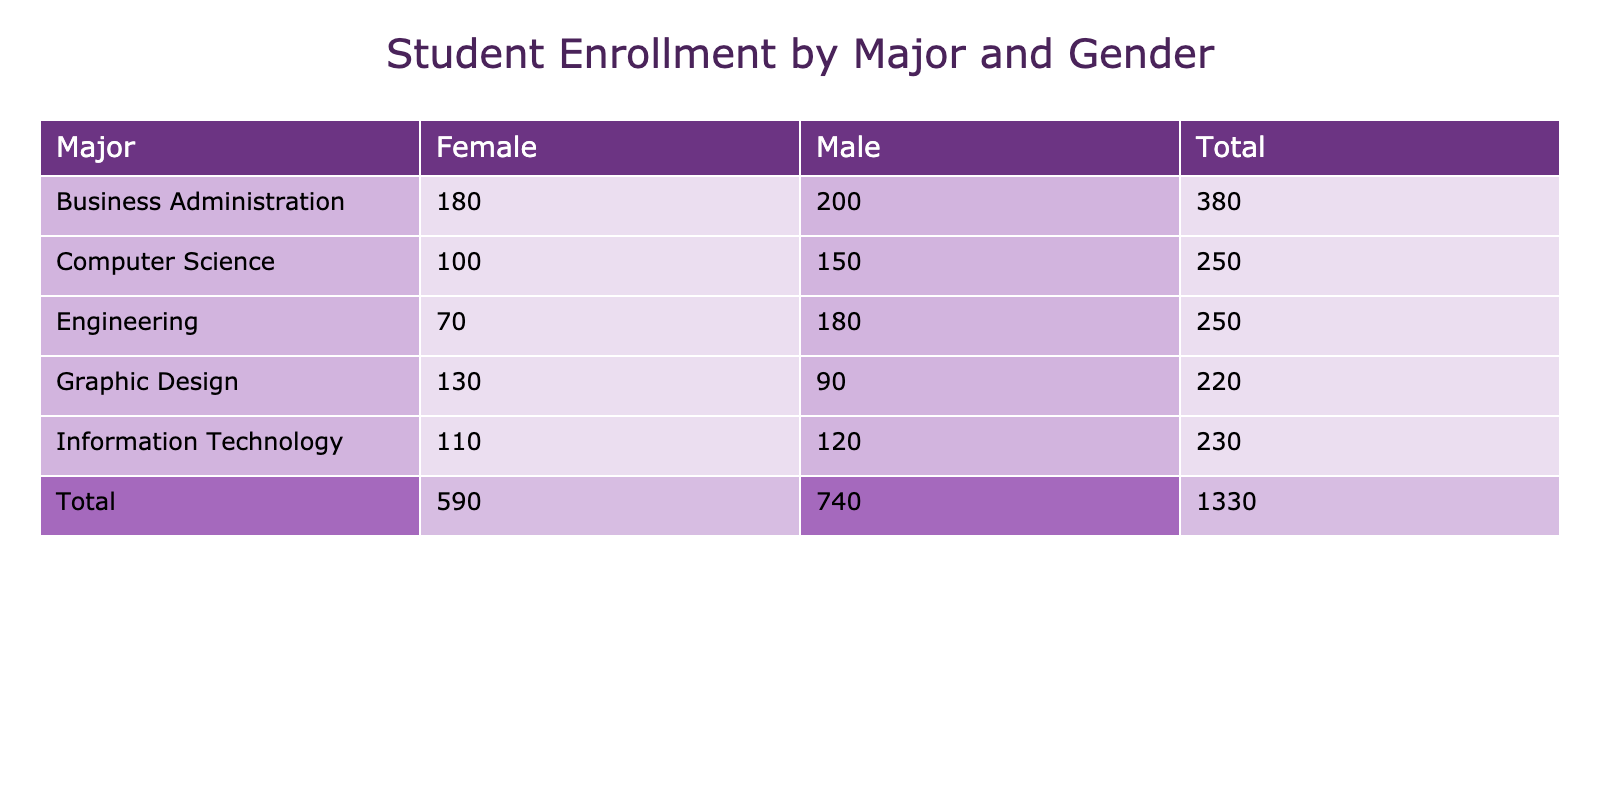What is the total number of female students in Engineering? In the table, we look under the Engineering major and find the number of female students, which is listed as 70.
Answer: 70 How many more male students are there in Business Administration than in Graphic Design? For Business Administration, there are 200 male students, and for Graphic Design, there are 90 male students. The difference is 200 - 90, which equals 110.
Answer: 110 Is the average GPA for females in Graphic Design higher than for males in the same major? The average GPA for females in Graphic Design is 3.6 and for males it is 3.4. Since 3.6 is greater than 3.4, the answer is yes.
Answer: Yes What is the total enrollment of Computer Science students? To find total enrollment in Computer Science, we add the number of male (150) and female students (100) which gives us 150 + 100 = 250.
Answer: 250 Which major has the highest number of male students? The table shows the number of male students for each major: Computer Science (150), Engineering (180), Business Administration (200), Graphic Design (90), and Information Technology (120). The highest value is 200 in Business Administration.
Answer: Business Administration What is the average number of students across all majors for female students? We look for the number of female students across each major: 100 (Computer Science) + 70 (Engineering) + 180 (Business Administration) + 130 (Graphic Design) + 110 (Information Technology) = 590. There are 5 majors, so the average is 590 divided by 5, which equals 118.
Answer: 118 Does Information Technology have more male students than Engineering? There are 120 male students in Information Technology and 180 male students in Engineering. Since 120 is less than 180, the answer is no.
Answer: No Calculate the combined average GPA of all students in Business Administration. The average GPAs for male and female in Business Administration are 3.1 and 3.3 respectively. We find the combined total by considering the weighted average based on the number of students: (200 male * 3.1 + 180 female * 3.3) / (200 + 180). Calculating this gives (620 + 594) / 380 = 1214 / 380 = 3.2.
Answer: 3.2 